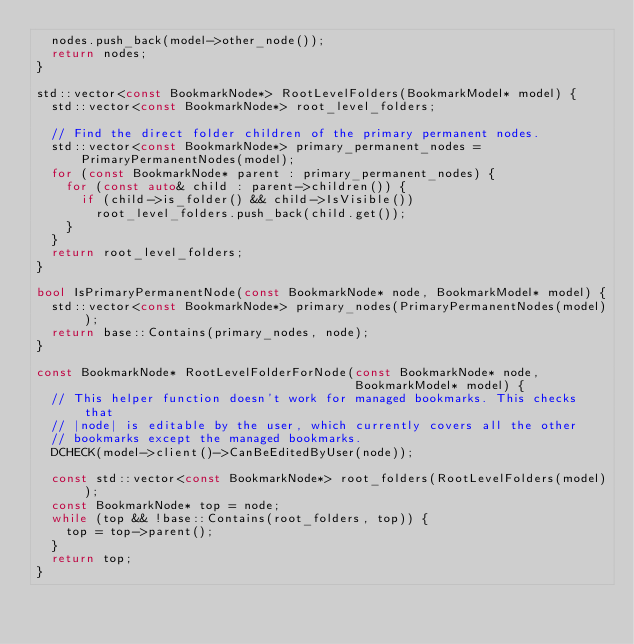Convert code to text. <code><loc_0><loc_0><loc_500><loc_500><_C++_>  nodes.push_back(model->other_node());
  return nodes;
}

std::vector<const BookmarkNode*> RootLevelFolders(BookmarkModel* model) {
  std::vector<const BookmarkNode*> root_level_folders;

  // Find the direct folder children of the primary permanent nodes.
  std::vector<const BookmarkNode*> primary_permanent_nodes =
      PrimaryPermanentNodes(model);
  for (const BookmarkNode* parent : primary_permanent_nodes) {
    for (const auto& child : parent->children()) {
      if (child->is_folder() && child->IsVisible())
        root_level_folders.push_back(child.get());
    }
  }
  return root_level_folders;
}

bool IsPrimaryPermanentNode(const BookmarkNode* node, BookmarkModel* model) {
  std::vector<const BookmarkNode*> primary_nodes(PrimaryPermanentNodes(model));
  return base::Contains(primary_nodes, node);
}

const BookmarkNode* RootLevelFolderForNode(const BookmarkNode* node,
                                           BookmarkModel* model) {
  // This helper function doesn't work for managed bookmarks. This checks that
  // |node| is editable by the user, which currently covers all the other
  // bookmarks except the managed bookmarks.
  DCHECK(model->client()->CanBeEditedByUser(node));

  const std::vector<const BookmarkNode*> root_folders(RootLevelFolders(model));
  const BookmarkNode* top = node;
  while (top && !base::Contains(root_folders, top)) {
    top = top->parent();
  }
  return top;
}
</code> 